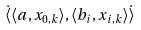Convert formula to latex. <formula><loc_0><loc_0><loc_500><loc_500>\dot { \langle } \langle a , x _ { 0 , k } \rangle , \langle b _ { i } , x _ { i , k } \rangle \dot { \rangle }</formula> 